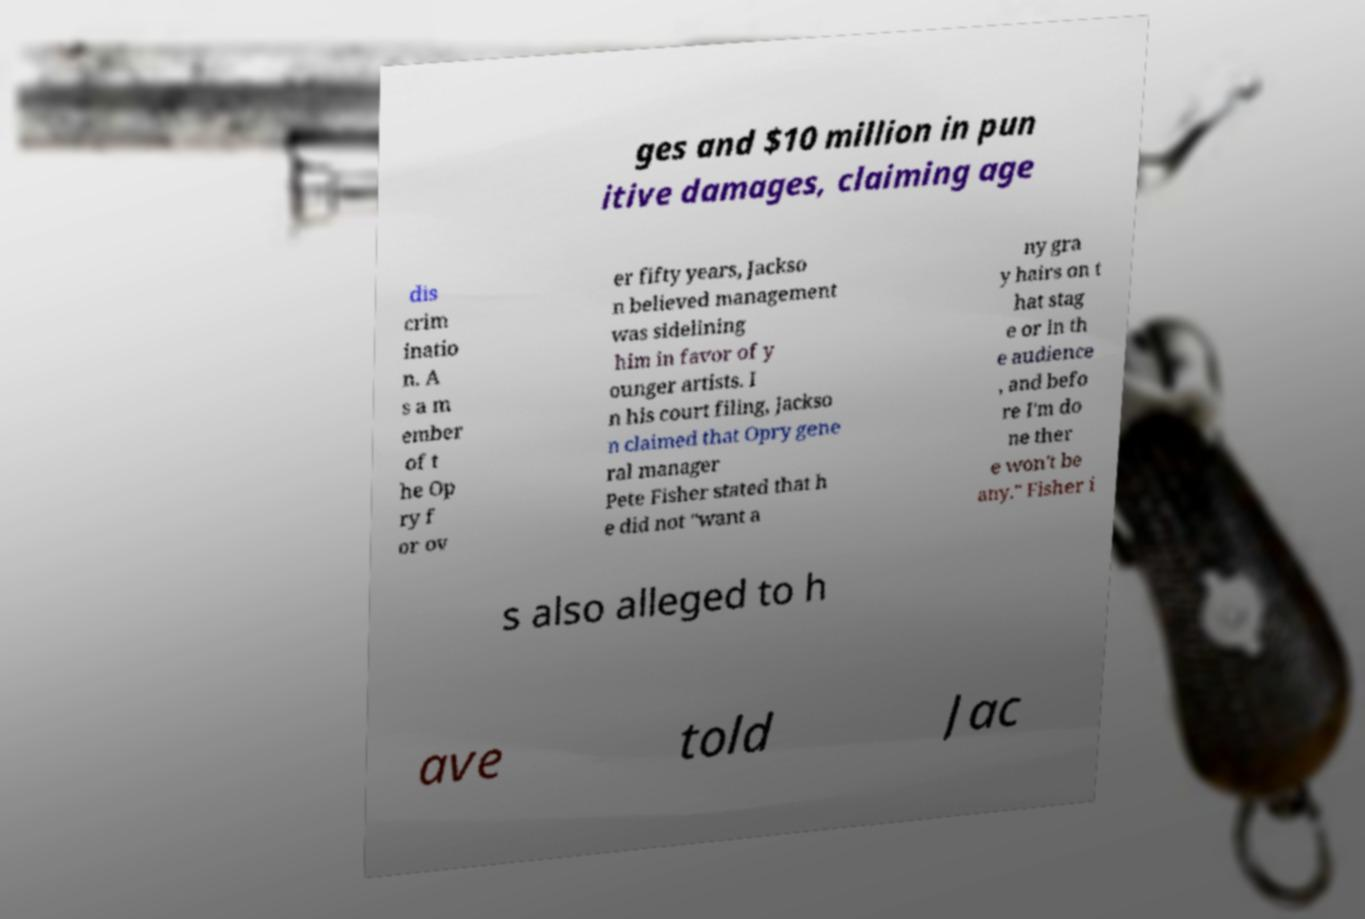For documentation purposes, I need the text within this image transcribed. Could you provide that? ges and $10 million in pun itive damages, claiming age dis crim inatio n. A s a m ember of t he Op ry f or ov er fifty years, Jackso n believed management was sidelining him in favor of y ounger artists. I n his court filing, Jackso n claimed that Opry gene ral manager Pete Fisher stated that h e did not "want a ny gra y hairs on t hat stag e or in th e audience , and befo re I'm do ne ther e won't be any." Fisher i s also alleged to h ave told Jac 